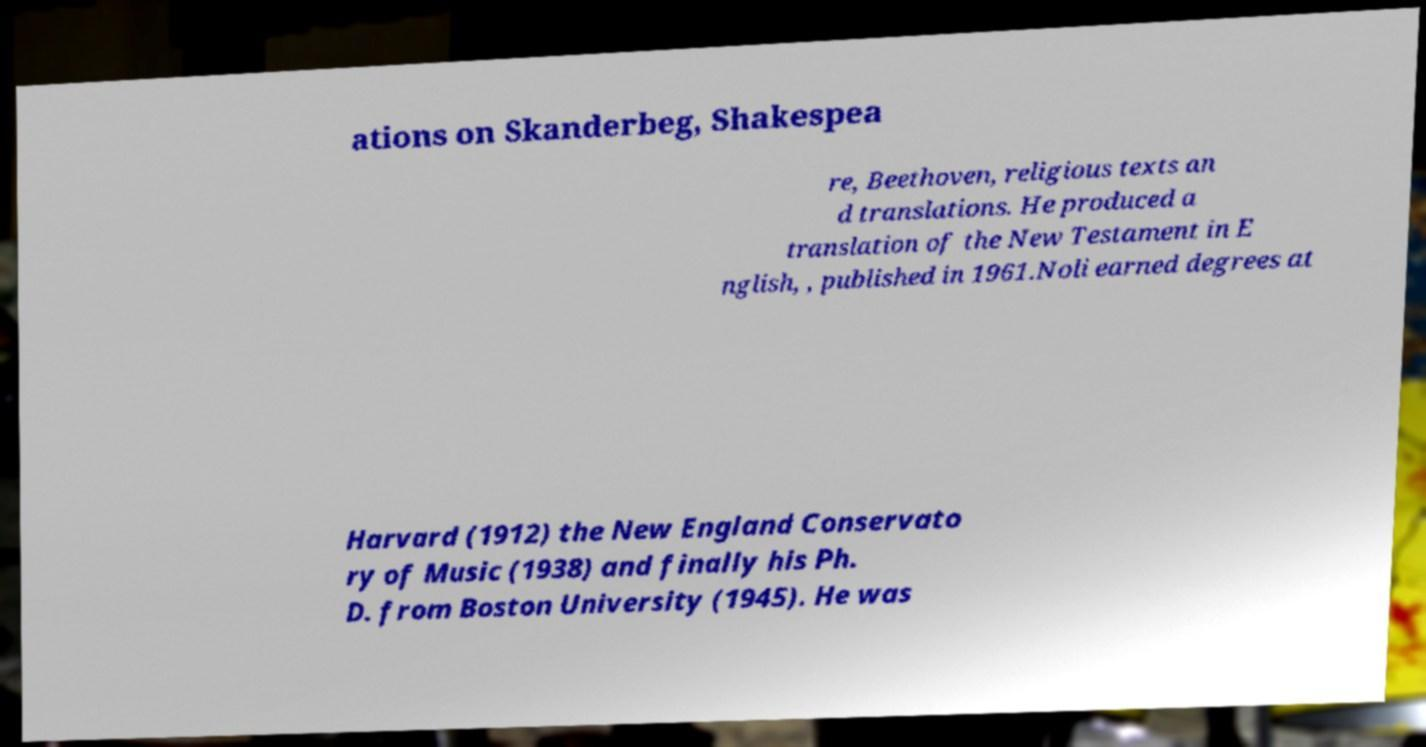I need the written content from this picture converted into text. Can you do that? ations on Skanderbeg, Shakespea re, Beethoven, religious texts an d translations. He produced a translation of the New Testament in E nglish, , published in 1961.Noli earned degrees at Harvard (1912) the New England Conservato ry of Music (1938) and finally his Ph. D. from Boston University (1945). He was 